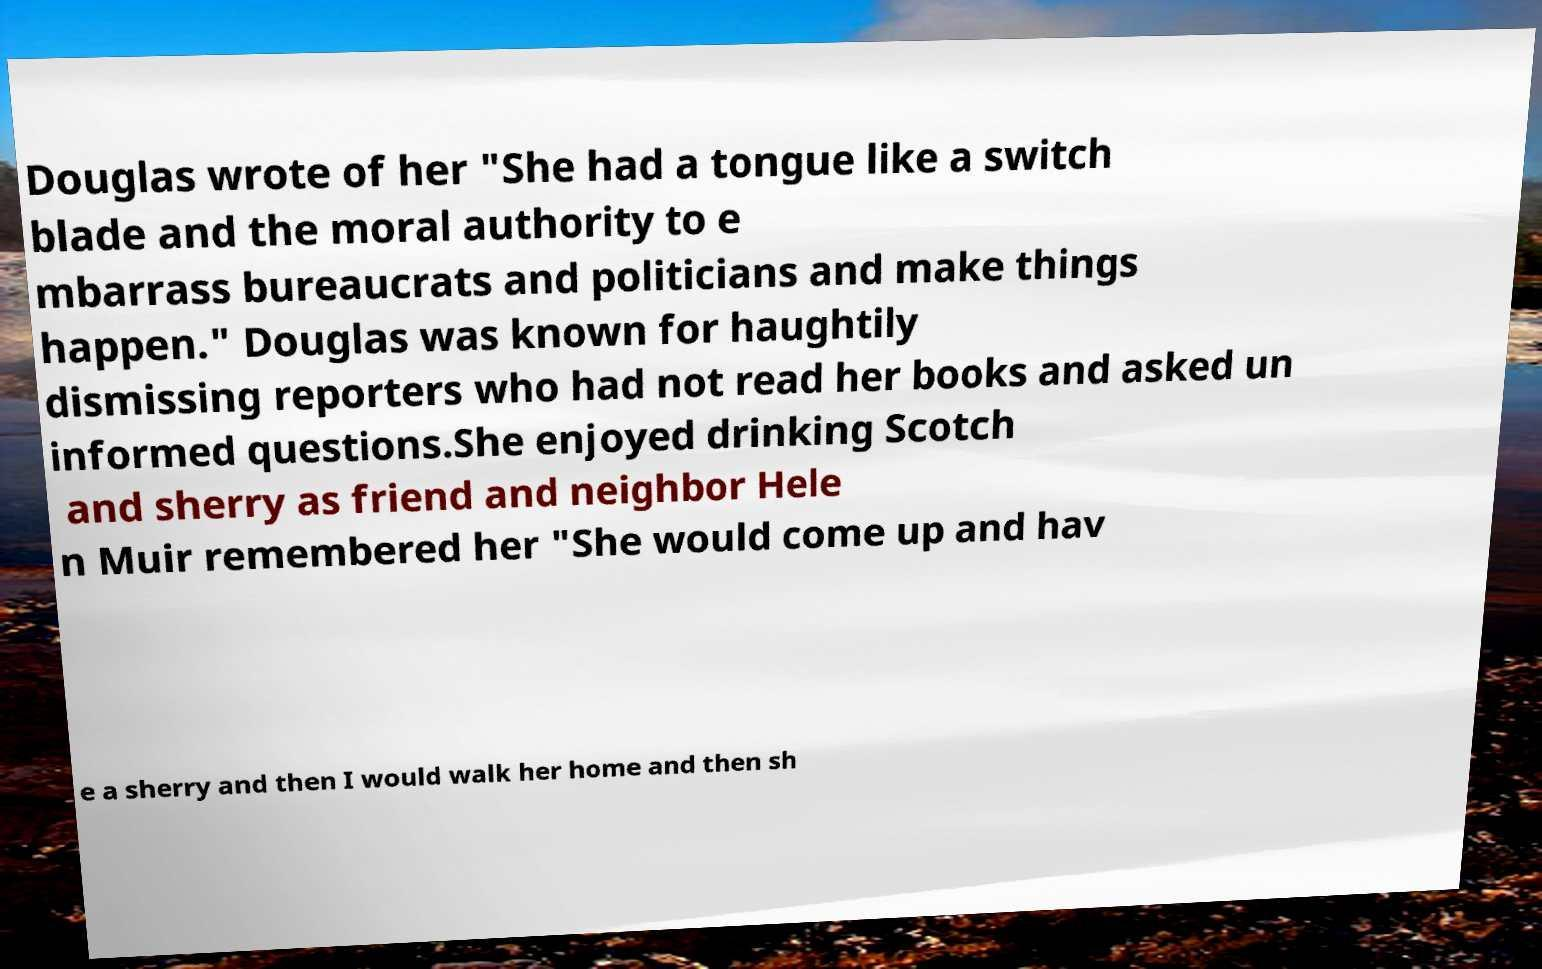Could you extract and type out the text from this image? Douglas wrote of her "She had a tongue like a switch blade and the moral authority to e mbarrass bureaucrats and politicians and make things happen." Douglas was known for haughtily dismissing reporters who had not read her books and asked un informed questions.She enjoyed drinking Scotch and sherry as friend and neighbor Hele n Muir remembered her "She would come up and hav e a sherry and then I would walk her home and then sh 